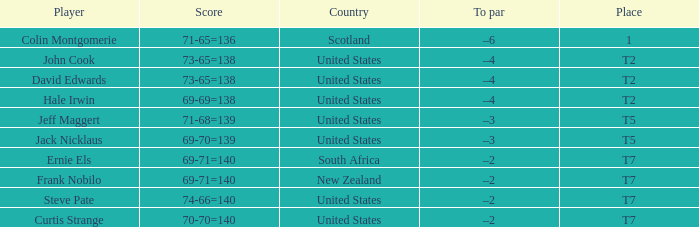What is the name of the golfer that has the score of 73-65=138? John Cook, David Edwards. 